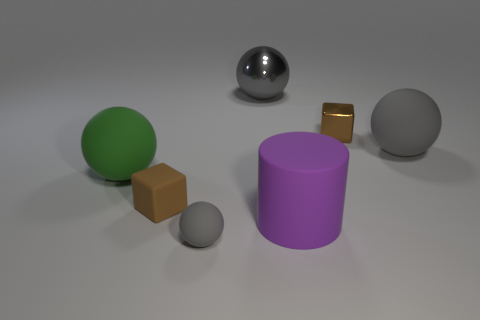Subtract all brown cubes. How many were subtracted if there are1brown cubes left? 1 Subtract all tiny gray balls. How many balls are left? 3 Add 3 tiny purple matte spheres. How many objects exist? 10 Subtract all green blocks. How many gray balls are left? 3 Subtract all green balls. How many balls are left? 3 Subtract 2 balls. How many balls are left? 2 Subtract all brown rubber objects. Subtract all gray shiny things. How many objects are left? 5 Add 7 brown shiny cubes. How many brown shiny cubes are left? 8 Add 1 gray shiny things. How many gray shiny things exist? 2 Subtract 0 red balls. How many objects are left? 7 